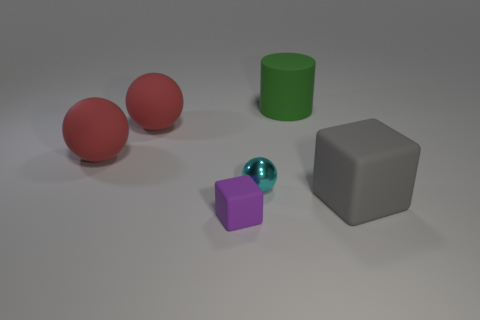Is there any other thing that has the same material as the cyan ball?
Provide a short and direct response. No. How many other things are the same size as the purple cube?
Provide a succinct answer. 1. The small object that is right of the rubber block that is to the left of the cyan shiny sphere left of the large gray thing is what shape?
Provide a succinct answer. Sphere. How many objects are either objects that are in front of the green matte thing or rubber blocks to the left of the matte cylinder?
Provide a succinct answer. 5. What is the size of the cube that is left of the large rubber cylinder left of the big gray matte object?
Provide a succinct answer. Small. Are there any big red rubber things of the same shape as the metallic thing?
Provide a succinct answer. Yes. What color is the cube that is the same size as the green cylinder?
Provide a short and direct response. Gray. What is the size of the block that is right of the small cyan sphere?
Keep it short and to the point. Large. There is a tiny thing that is behind the purple rubber block; are there any large cubes behind it?
Your response must be concise. No. Is the material of the block to the left of the tiny cyan metallic thing the same as the green cylinder?
Your answer should be very brief. Yes. 